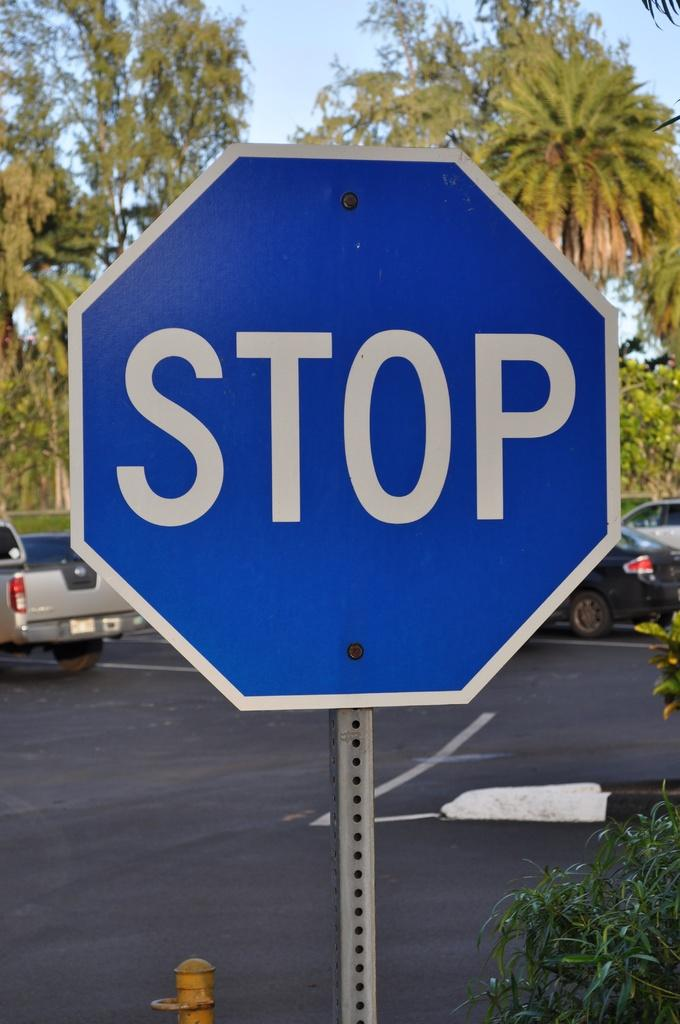Provide a one-sentence caption for the provided image. A close view of a stop sign that is blue instead or red. 